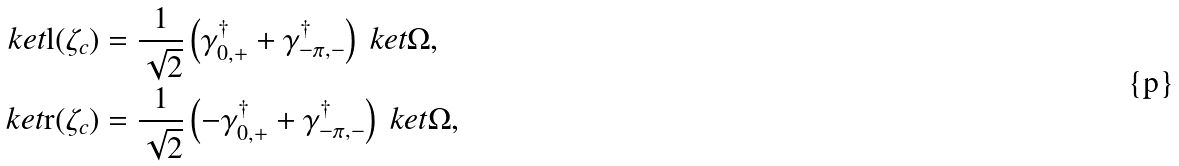Convert formula to latex. <formula><loc_0><loc_0><loc_500><loc_500>\ k e t { \text {l} ( \zeta _ { c } ) } & = \frac { 1 } { \sqrt { 2 } } \left ( \gamma ^ { \dagger } _ { 0 , + } + \gamma ^ { \dagger } _ { - \pi , - } \right ) \ k e t { \Omega } , \\ \ k e t { \text {r} ( \zeta _ { c } ) } & = \frac { 1 } { \sqrt { 2 } } \left ( - \gamma ^ { \dagger } _ { 0 , + } + \gamma ^ { \dagger } _ { - \pi , - } \right ) \ k e t { \Omega } ,</formula> 